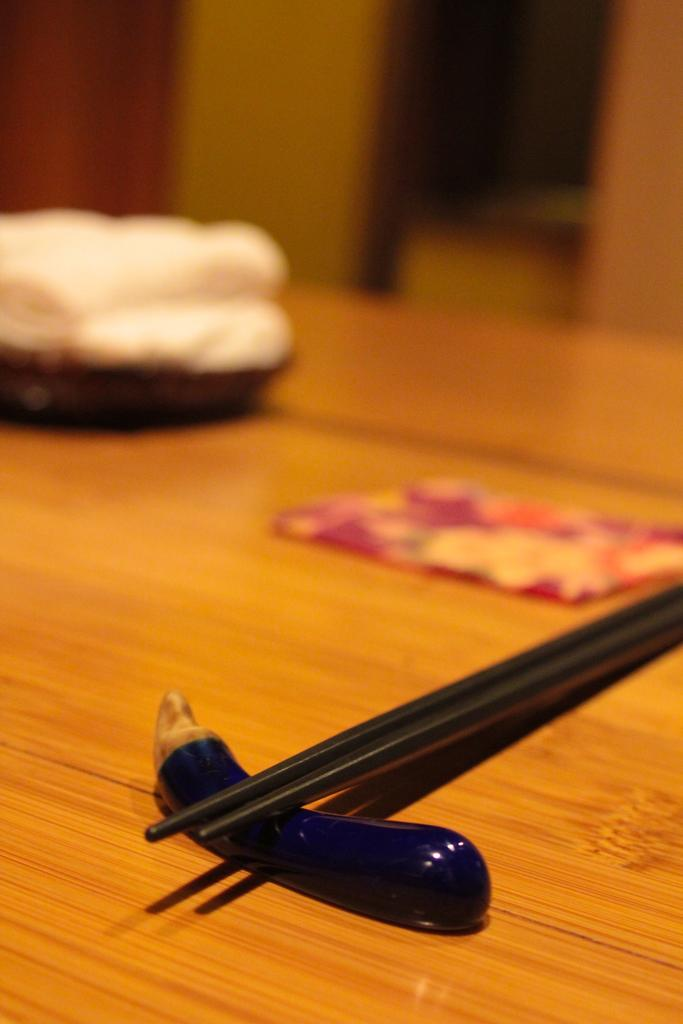What piece of furniture is present in the image? There is a table in the image. What utensils can be seen on the table? Chopsticks are on the table. What is likely to be placed on the plate on the table? The presence of chopsticks suggests that there might be food on the plate. What type of fish can be seen swimming in the plate on the table? There is no fish present in the image; the plate is empty. Can you tell me how many crows are sitting on the table in the image? There are no crows present in the image; the table only has chopsticks and a plate on it. 